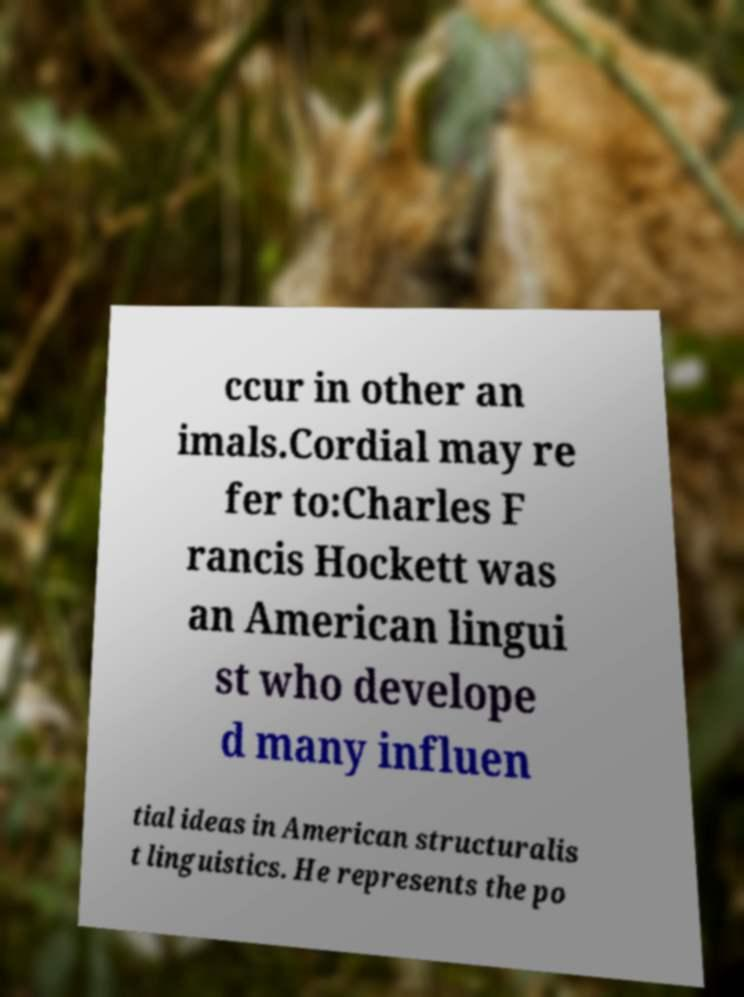Can you read and provide the text displayed in the image?This photo seems to have some interesting text. Can you extract and type it out for me? ccur in other an imals.Cordial may re fer to:Charles F rancis Hockett was an American lingui st who develope d many influen tial ideas in American structuralis t linguistics. He represents the po 